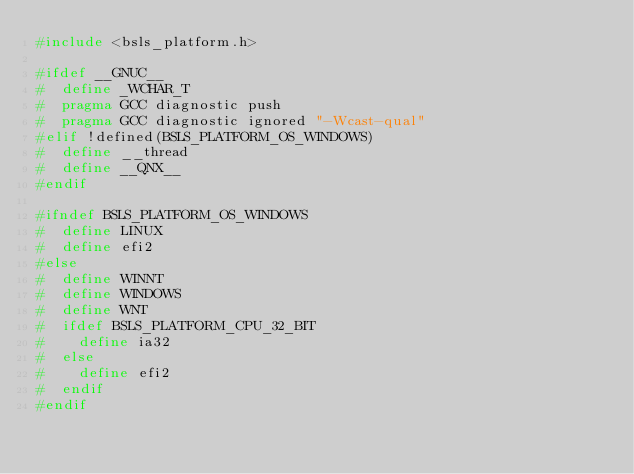Convert code to text. <code><loc_0><loc_0><loc_500><loc_500><_C++_>#include <bsls_platform.h>

#ifdef __GNUC__
#  define _WCHAR_T
#  pragma GCC diagnostic push
#  pragma GCC diagnostic ignored "-Wcast-qual"
#elif !defined(BSLS_PLATFORM_OS_WINDOWS)
#  define __thread
#  define __QNX__
#endif

#ifndef BSLS_PLATFORM_OS_WINDOWS
#  define LINUX
#  define efi2
#else
#  define WINNT
#  define WINDOWS
#  define WNT
#  ifdef BSLS_PLATFORM_CPU_32_BIT
#    define ia32
#  else
#    define efi2
#  endif
#endif
</code> 